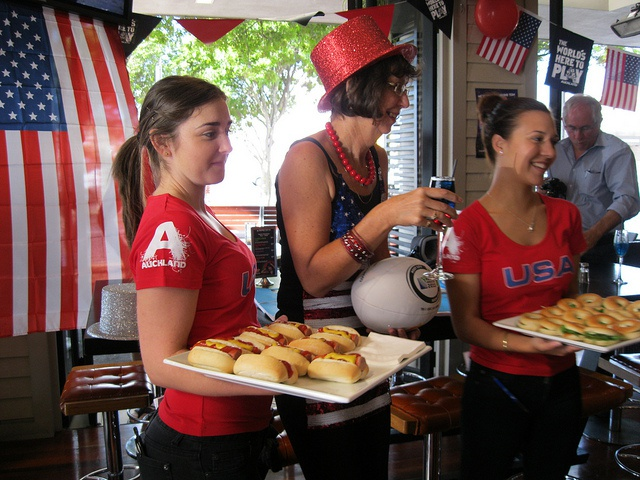Describe the objects in this image and their specific colors. I can see people in black, maroon, and brown tones, people in black, maroon, and brown tones, people in black, brown, maroon, and gray tones, sandwich in black, gray, maroon, and brown tones, and people in black, gray, and maroon tones in this image. 